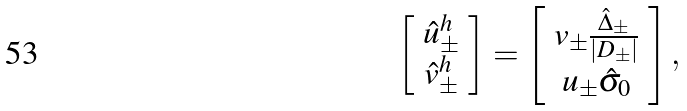Convert formula to latex. <formula><loc_0><loc_0><loc_500><loc_500>\left [ \begin{array} { c } \hat { u } ^ { h } _ { \pm } \\ \hat { v } ^ { h } _ { \pm } \end{array} \right ] = \left [ \begin{array} { c } v _ { \pm } \frac { \hat { \Delta } _ { \pm } } { | D _ { \pm } | } \\ u _ { \pm } \hat { \sigma } _ { 0 } \\ \end{array} \right ] ,</formula> 